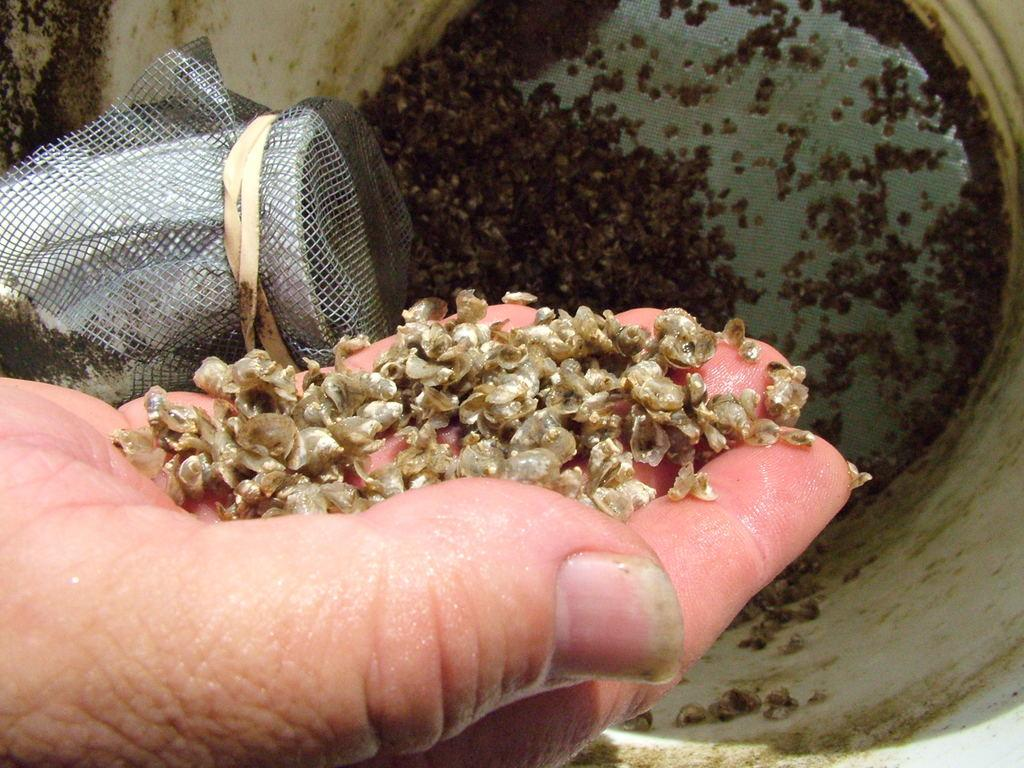What part of a person can be seen in the image? There is a person's hand in the image. What is the person holding in their hand? There is an object in the person's hand. What is located at the bottom of the image? There is a box at the bottom of the image. Is the person wearing a crown in the image? There is no crown visible in the image. What type of tray is being used by the person in the image? There is no tray present in the image. 